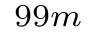Convert formula to latex. <formula><loc_0><loc_0><loc_500><loc_500>^ { 9 9 m }</formula> 